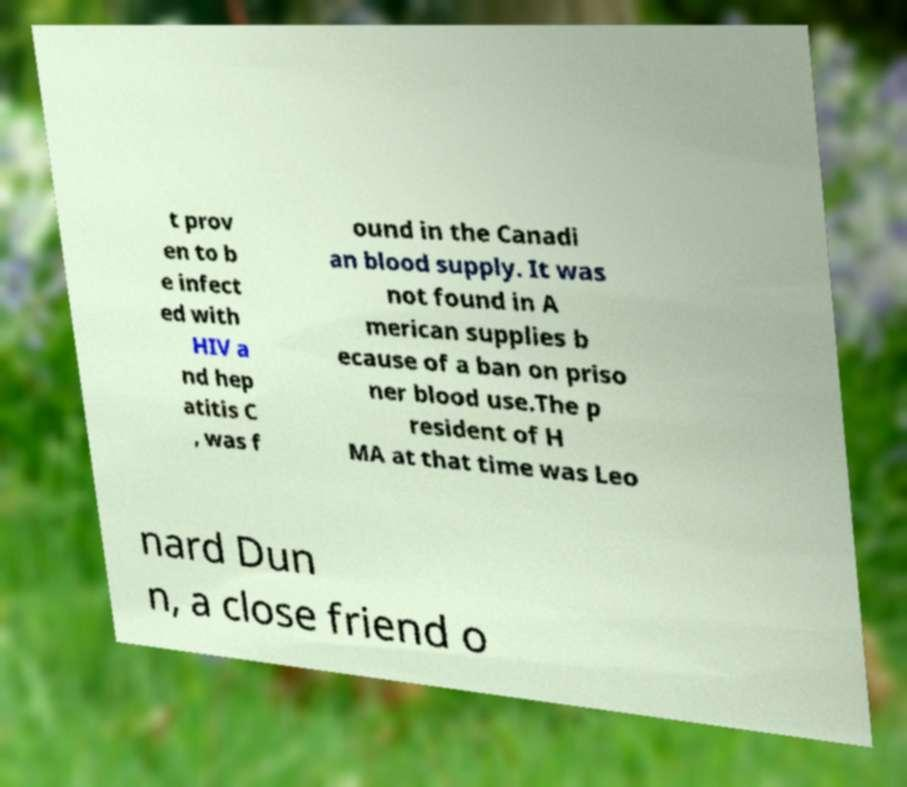Please identify and transcribe the text found in this image. t prov en to b e infect ed with HIV a nd hep atitis C , was f ound in the Canadi an blood supply. It was not found in A merican supplies b ecause of a ban on priso ner blood use.The p resident of H MA at that time was Leo nard Dun n, a close friend o 